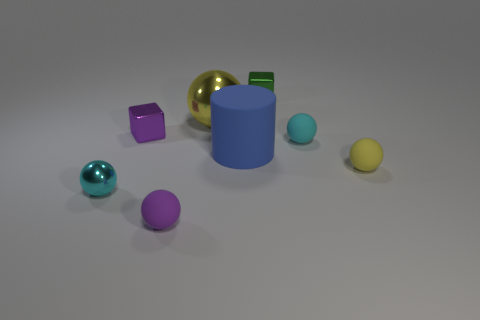What is the material of the tiny yellow thing that is the same shape as the large yellow object?
Provide a succinct answer. Rubber. What material is the cyan sphere right of the green thing?
Give a very brief answer. Rubber. What is the size of the blue cylinder that is the same material as the small purple sphere?
Your answer should be compact. Large. What number of cyan matte objects are the same shape as the small yellow rubber thing?
Keep it short and to the point. 1. There is a tiny yellow rubber thing; does it have the same shape as the thing in front of the small shiny ball?
Make the answer very short. Yes. There is a small thing that is the same color as the small metal sphere; what is its shape?
Provide a short and direct response. Sphere. Are there any small green spheres that have the same material as the tiny purple ball?
Keep it short and to the point. No. There is a small sphere in front of the small metallic object that is in front of the big blue thing; what is its material?
Keep it short and to the point. Rubber. There is a metal block that is to the right of the small purple metal thing on the left side of the tiny block to the right of the big blue cylinder; what size is it?
Keep it short and to the point. Small. How many other objects are there of the same shape as the small cyan matte thing?
Make the answer very short. 4. 